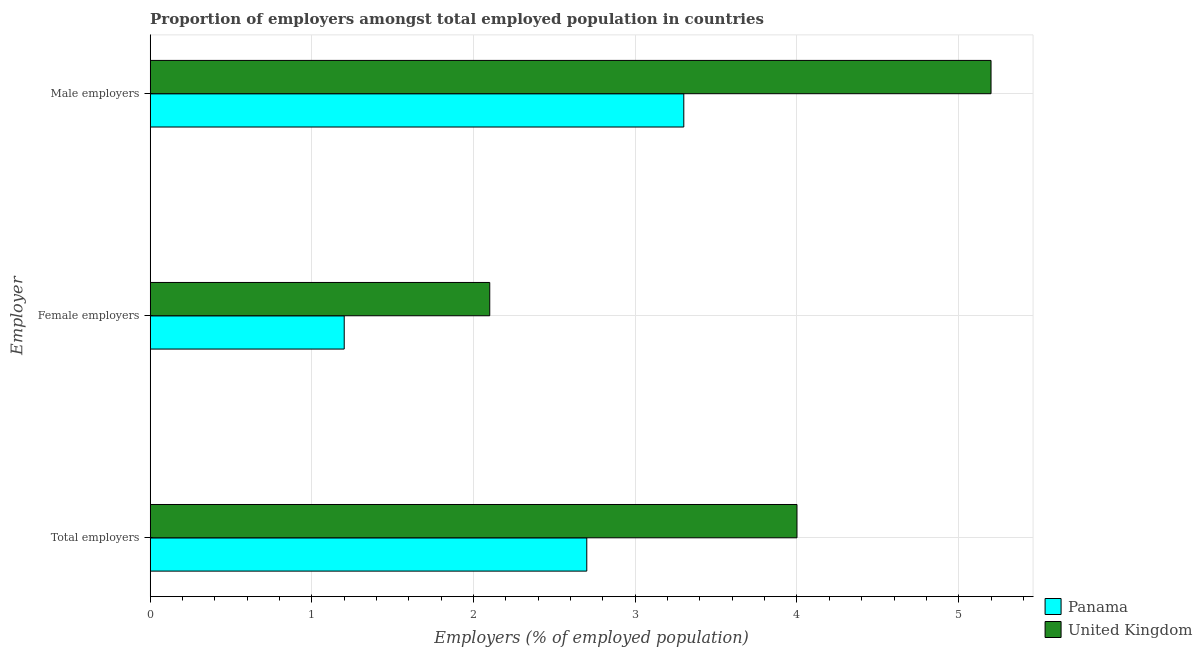Are the number of bars per tick equal to the number of legend labels?
Make the answer very short. Yes. Are the number of bars on each tick of the Y-axis equal?
Provide a succinct answer. Yes. How many bars are there on the 3rd tick from the top?
Your answer should be very brief. 2. How many bars are there on the 3rd tick from the bottom?
Make the answer very short. 2. What is the label of the 1st group of bars from the top?
Give a very brief answer. Male employers. What is the percentage of total employers in Panama?
Ensure brevity in your answer.  2.7. Across all countries, what is the maximum percentage of male employers?
Give a very brief answer. 5.2. Across all countries, what is the minimum percentage of total employers?
Provide a short and direct response. 2.7. In which country was the percentage of total employers minimum?
Offer a very short reply. Panama. What is the total percentage of male employers in the graph?
Give a very brief answer. 8.5. What is the difference between the percentage of total employers in Panama and that in United Kingdom?
Ensure brevity in your answer.  -1.3. What is the difference between the percentage of female employers in Panama and the percentage of male employers in United Kingdom?
Ensure brevity in your answer.  -4. What is the average percentage of total employers per country?
Your answer should be compact. 3.35. What is the difference between the percentage of male employers and percentage of total employers in Panama?
Give a very brief answer. 0.6. What is the ratio of the percentage of male employers in United Kingdom to that in Panama?
Offer a terse response. 1.58. Is the difference between the percentage of total employers in United Kingdom and Panama greater than the difference between the percentage of female employers in United Kingdom and Panama?
Your answer should be very brief. Yes. What is the difference between the highest and the second highest percentage of female employers?
Offer a very short reply. 0.9. What is the difference between the highest and the lowest percentage of total employers?
Give a very brief answer. 1.3. What does the 1st bar from the top in Total employers represents?
Give a very brief answer. United Kingdom. What does the 2nd bar from the bottom in Female employers represents?
Keep it short and to the point. United Kingdom. How many bars are there?
Your response must be concise. 6. Are all the bars in the graph horizontal?
Ensure brevity in your answer.  Yes. Does the graph contain any zero values?
Keep it short and to the point. No. How many legend labels are there?
Make the answer very short. 2. How are the legend labels stacked?
Keep it short and to the point. Vertical. What is the title of the graph?
Your response must be concise. Proportion of employers amongst total employed population in countries. Does "Armenia" appear as one of the legend labels in the graph?
Your response must be concise. No. What is the label or title of the X-axis?
Ensure brevity in your answer.  Employers (% of employed population). What is the label or title of the Y-axis?
Provide a succinct answer. Employer. What is the Employers (% of employed population) in Panama in Total employers?
Your answer should be compact. 2.7. What is the Employers (% of employed population) of Panama in Female employers?
Your answer should be very brief. 1.2. What is the Employers (% of employed population) in United Kingdom in Female employers?
Keep it short and to the point. 2.1. What is the Employers (% of employed population) in Panama in Male employers?
Give a very brief answer. 3.3. What is the Employers (% of employed population) in United Kingdom in Male employers?
Offer a terse response. 5.2. Across all Employer, what is the maximum Employers (% of employed population) of Panama?
Offer a terse response. 3.3. Across all Employer, what is the maximum Employers (% of employed population) in United Kingdom?
Offer a very short reply. 5.2. Across all Employer, what is the minimum Employers (% of employed population) in Panama?
Keep it short and to the point. 1.2. Across all Employer, what is the minimum Employers (% of employed population) of United Kingdom?
Keep it short and to the point. 2.1. What is the difference between the Employers (% of employed population) in United Kingdom in Total employers and that in Female employers?
Your response must be concise. 1.9. What is the difference between the Employers (% of employed population) in Panama in Total employers and that in Male employers?
Offer a terse response. -0.6. What is the difference between the Employers (% of employed population) of Panama in Female employers and the Employers (% of employed population) of United Kingdom in Male employers?
Your answer should be compact. -4. What is the average Employers (% of employed population) of Panama per Employer?
Give a very brief answer. 2.4. What is the average Employers (% of employed population) in United Kingdom per Employer?
Your answer should be compact. 3.77. What is the difference between the Employers (% of employed population) in Panama and Employers (% of employed population) in United Kingdom in Total employers?
Ensure brevity in your answer.  -1.3. What is the difference between the Employers (% of employed population) of Panama and Employers (% of employed population) of United Kingdom in Female employers?
Keep it short and to the point. -0.9. What is the ratio of the Employers (% of employed population) of Panama in Total employers to that in Female employers?
Provide a succinct answer. 2.25. What is the ratio of the Employers (% of employed population) in United Kingdom in Total employers to that in Female employers?
Give a very brief answer. 1.9. What is the ratio of the Employers (% of employed population) in Panama in Total employers to that in Male employers?
Your answer should be very brief. 0.82. What is the ratio of the Employers (% of employed population) in United Kingdom in Total employers to that in Male employers?
Offer a very short reply. 0.77. What is the ratio of the Employers (% of employed population) of Panama in Female employers to that in Male employers?
Your response must be concise. 0.36. What is the ratio of the Employers (% of employed population) in United Kingdom in Female employers to that in Male employers?
Provide a succinct answer. 0.4. What is the difference between the highest and the second highest Employers (% of employed population) of United Kingdom?
Your answer should be very brief. 1.2. What is the difference between the highest and the lowest Employers (% of employed population) of United Kingdom?
Ensure brevity in your answer.  3.1. 